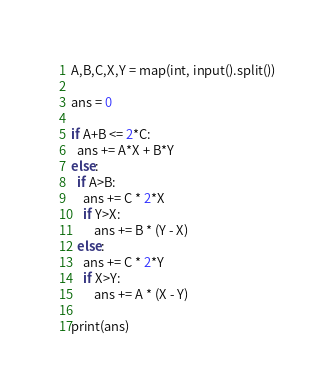Convert code to text. <code><loc_0><loc_0><loc_500><loc_500><_Python_>A,B,C,X,Y = map(int, input().split())

ans = 0

if A+B <= 2*C:
  ans += A*X + B*Y
else:
  if A>B:
    ans += C * 2*X
    if Y>X:
	    ans += B * (Y - X)
  else:
    ans += C * 2*Y
    if X>Y:
	    ans += A * (X - Y)
    
print(ans)</code> 